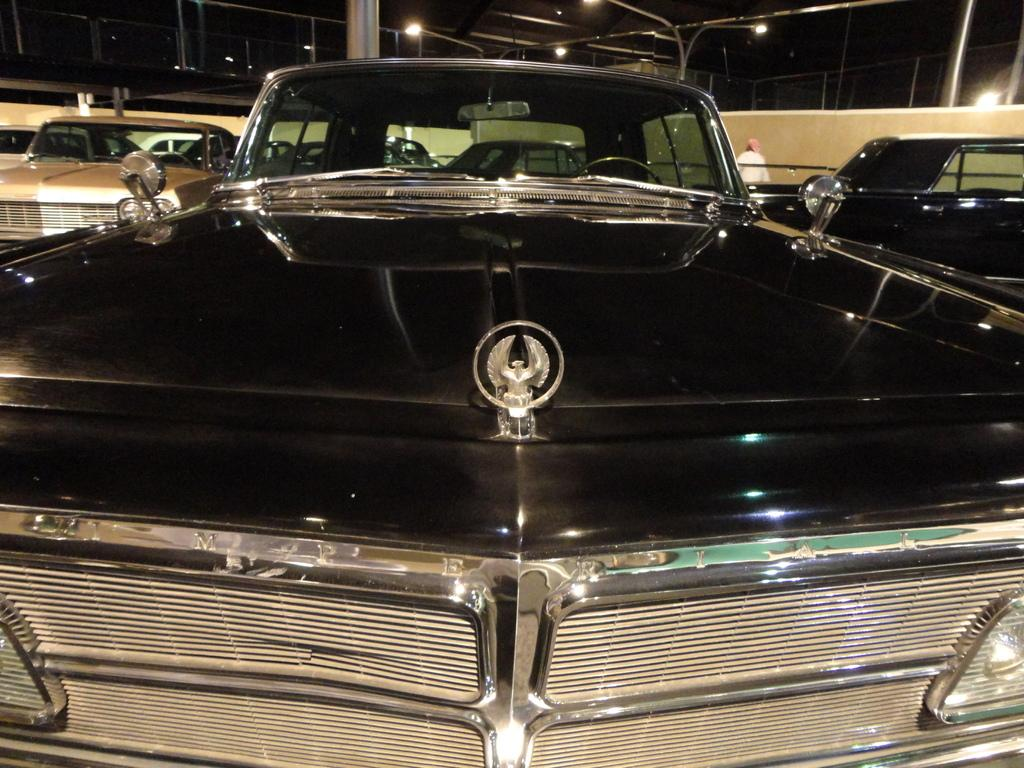What type of vehicles can be seen in the image? There are cars in the image. What structure is present in the image? There is a wall in the image. Can you describe the person in the image? There is a person standing in the image. What can be seen in the background of the image? There are lights and rods visible in the background of the image. How does the person in the image tie a knot with the rods in the background? There is no knot or interaction between the person and the rods in the image; the person is simply standing near them. What hour of the day is depicted in the image? The provided facts do not give any information about the time of day, so it cannot be determined from the image. 